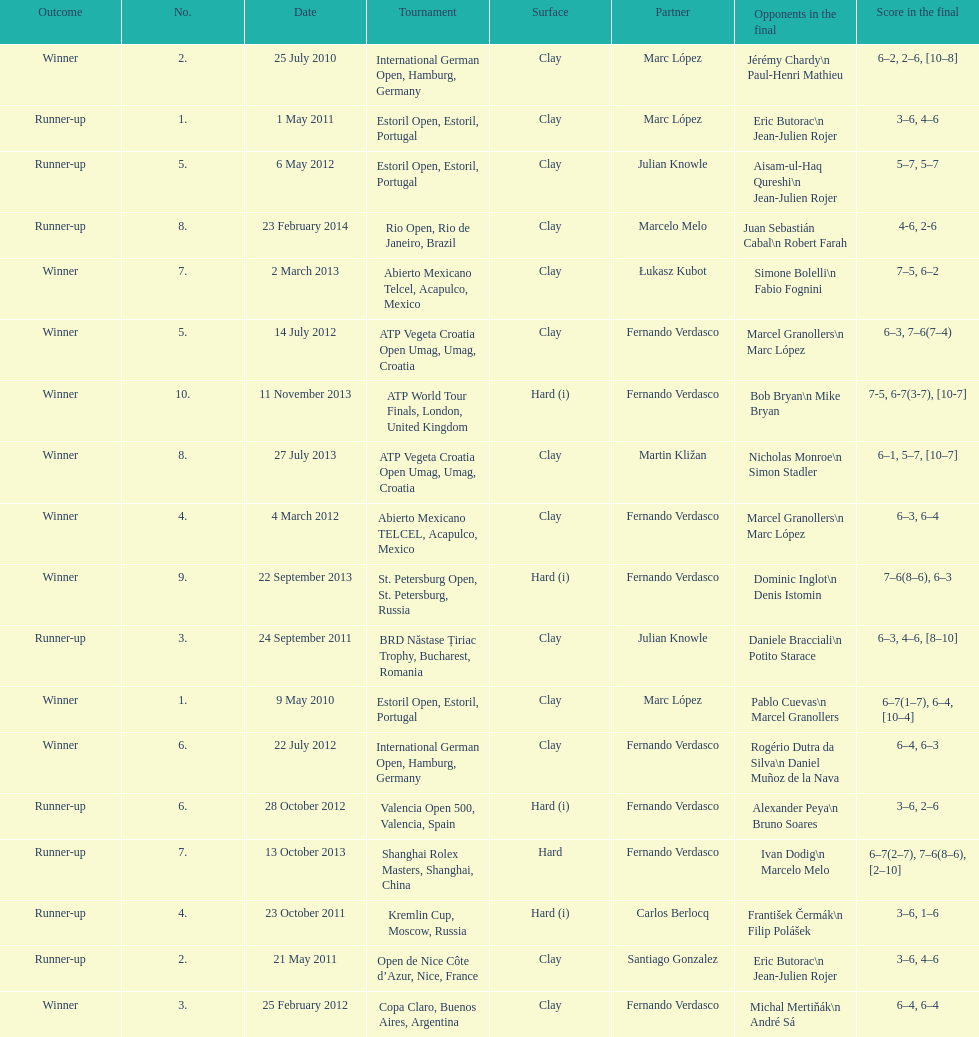How many tournaments has this player won in his career so far? 10. 